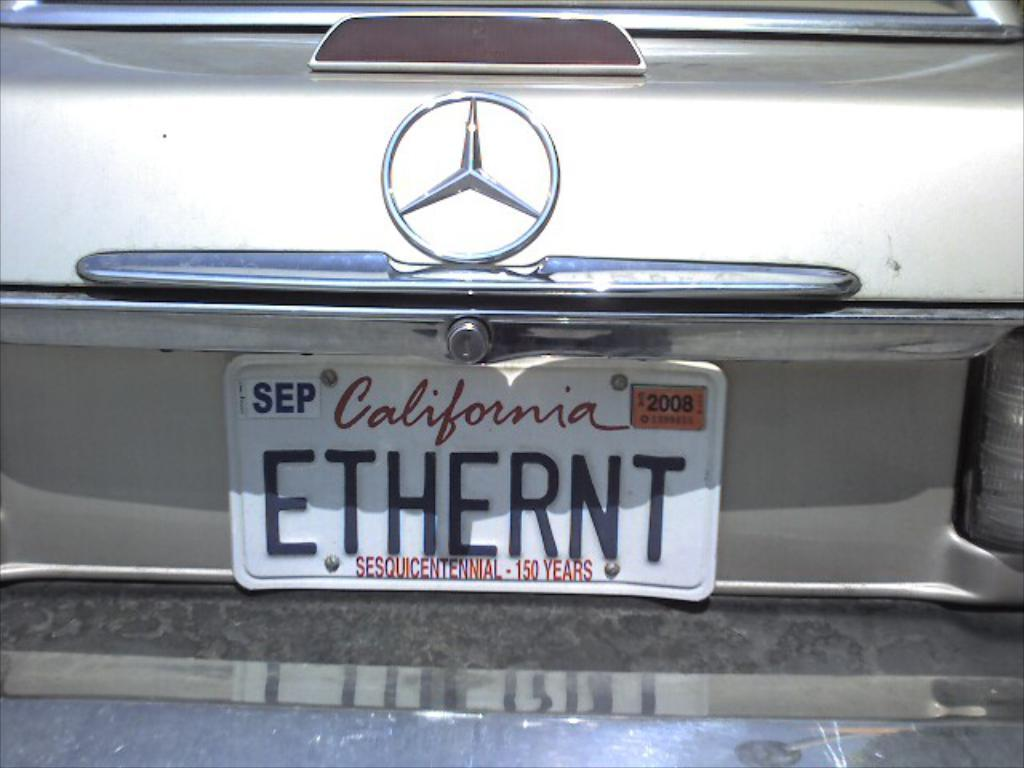<image>
Provide a brief description of the given image. A California license plate that reads "Ethernt" is affixed to a car. 